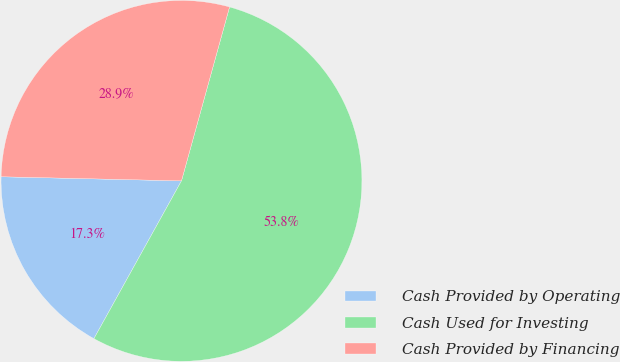Convert chart to OTSL. <chart><loc_0><loc_0><loc_500><loc_500><pie_chart><fcel>Cash Provided by Operating<fcel>Cash Used for Investing<fcel>Cash Provided by Financing<nl><fcel>17.3%<fcel>53.77%<fcel>28.93%<nl></chart> 